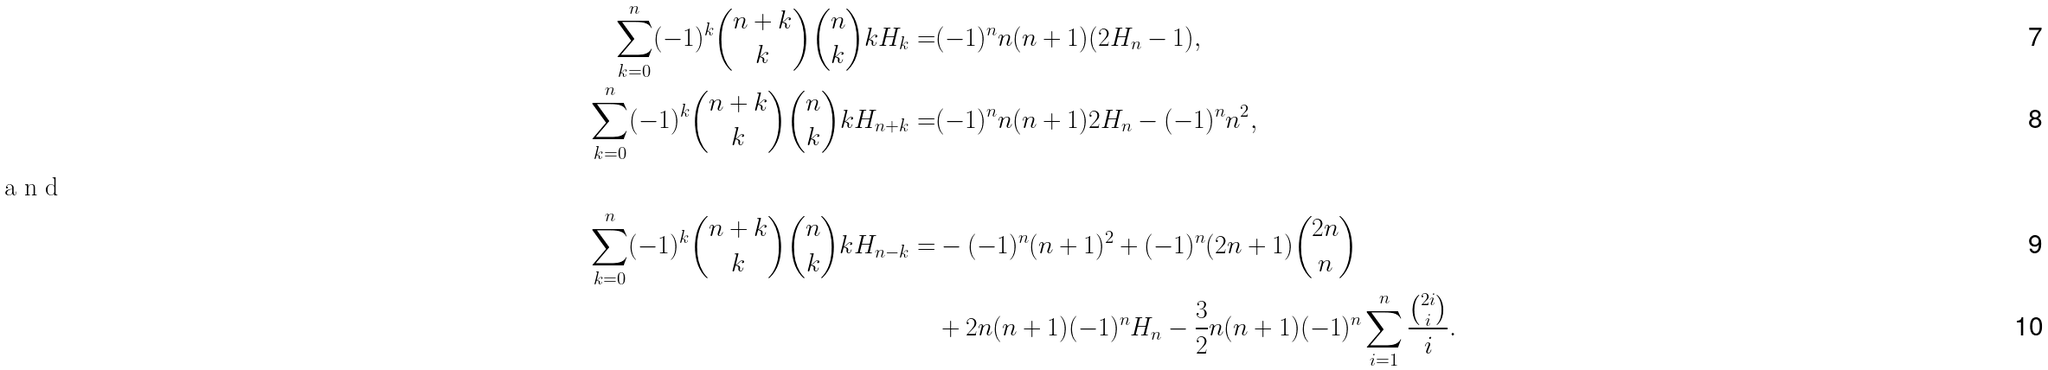<formula> <loc_0><loc_0><loc_500><loc_500>\sum _ { k = 0 } ^ { n } ( - 1 ) ^ { k } \binom { n + k } { k } \binom { n } { k } k H _ { k } = & ( - 1 ) ^ { n } n ( n + 1 ) ( 2 H _ { n } - 1 ) , \\ \sum _ { k = 0 } ^ { n } ( - 1 ) ^ { k } \binom { n + k } { k } \binom { n } { k } k H _ { n + k } = & ( - 1 ) ^ { n } n ( n + 1 ) 2 H _ { n } - ( - 1 ) ^ { n } n ^ { 2 } , \\ \intertext { a n d } \sum _ { k = 0 } ^ { n } ( - 1 ) ^ { k } \binom { n + k } { k } \binom { n } { k } k H _ { n - k } = & - ( - 1 ) ^ { n } ( n + 1 ) ^ { 2 } + ( - 1 ) ^ { n } ( 2 n + 1 ) \binom { 2 n } { n } \\ & + 2 n ( n + 1 ) ( - 1 ) ^ { n } H _ { n } - \frac { 3 } { 2 } n ( n + 1 ) ( - 1 ) ^ { n } \sum _ { i = 1 } ^ { n } \frac { \binom { 2 i } { i } } { i } .</formula> 